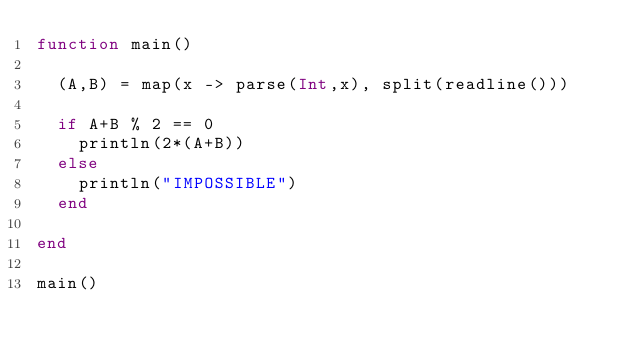Convert code to text. <code><loc_0><loc_0><loc_500><loc_500><_Julia_>function main()
  
  (A,B) = map(x -> parse(Int,x), split(readline()))
  
  if A+B % 2 == 0
    println(2*(A+B))
  else
    println("IMPOSSIBLE")
  end
  
end

main()</code> 